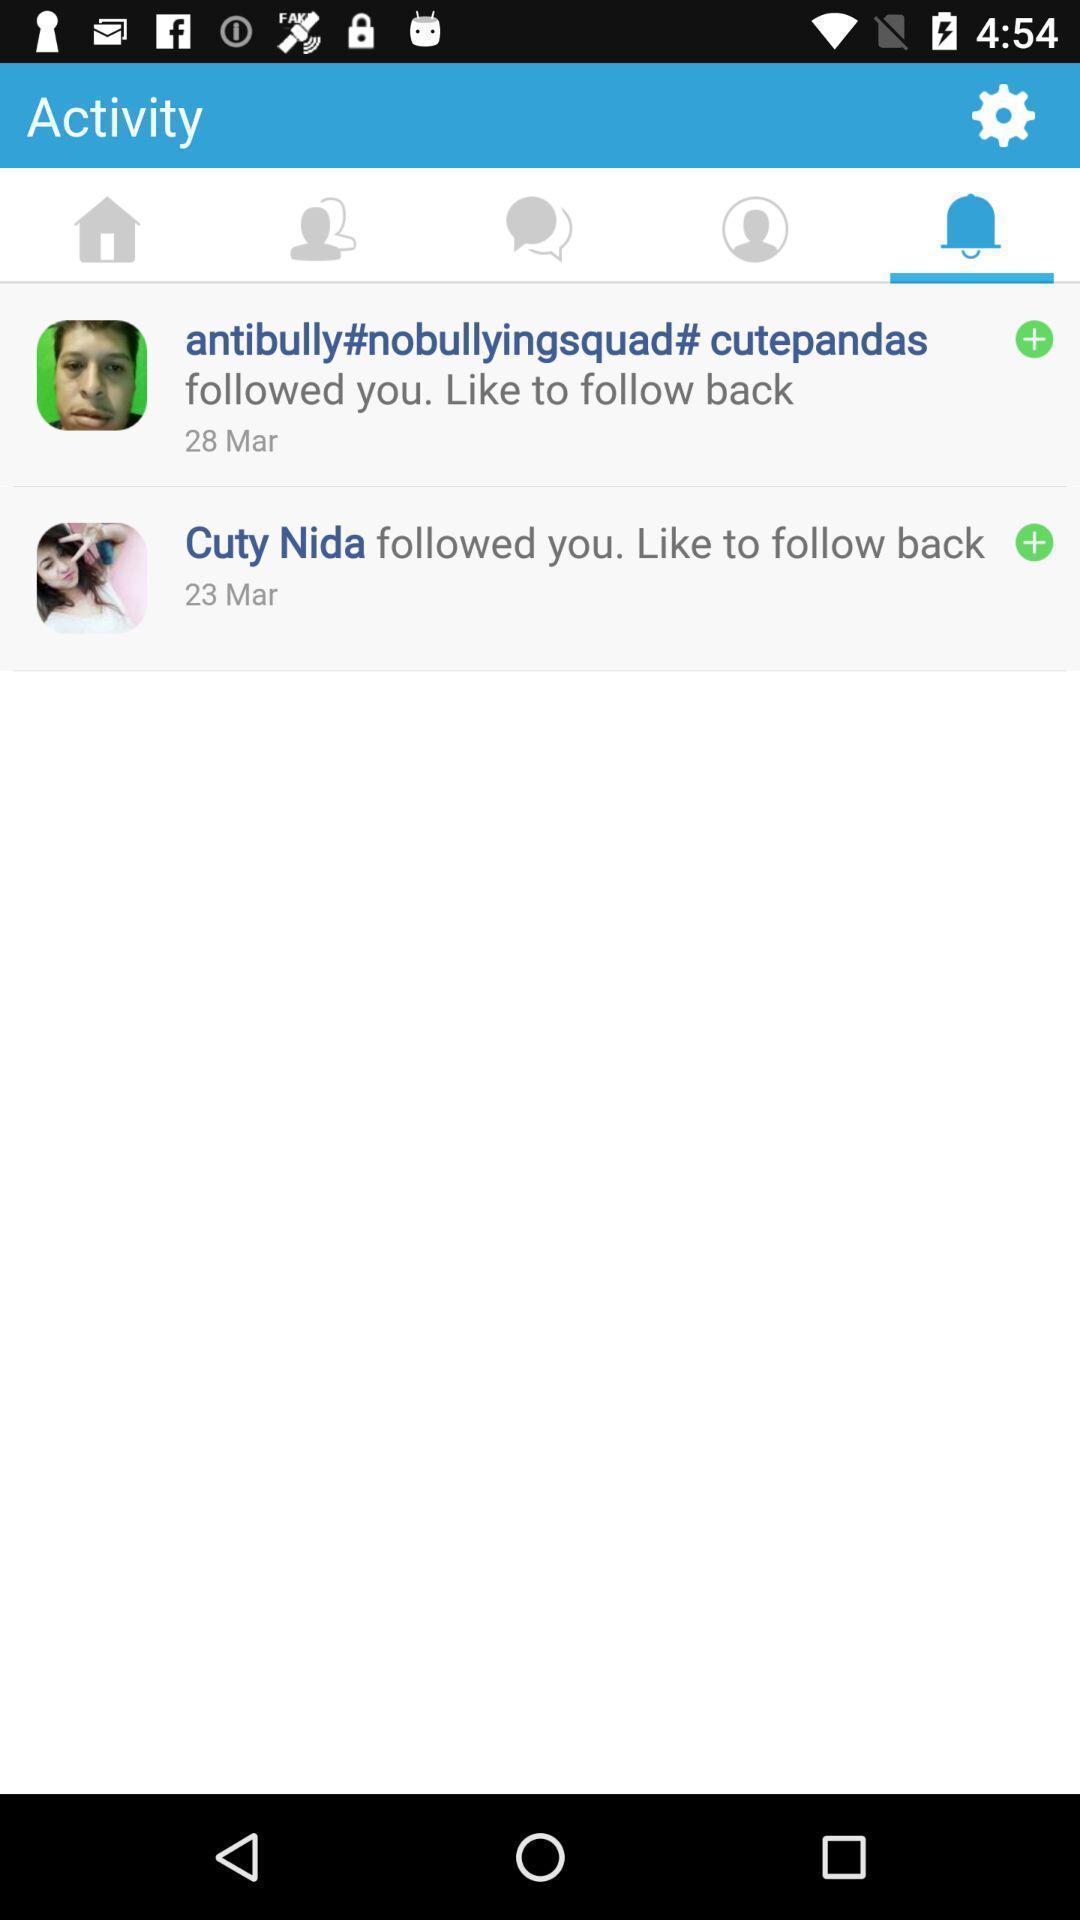Describe the key features of this screenshot. Screen displaying multiple users profile information in alerts page. 